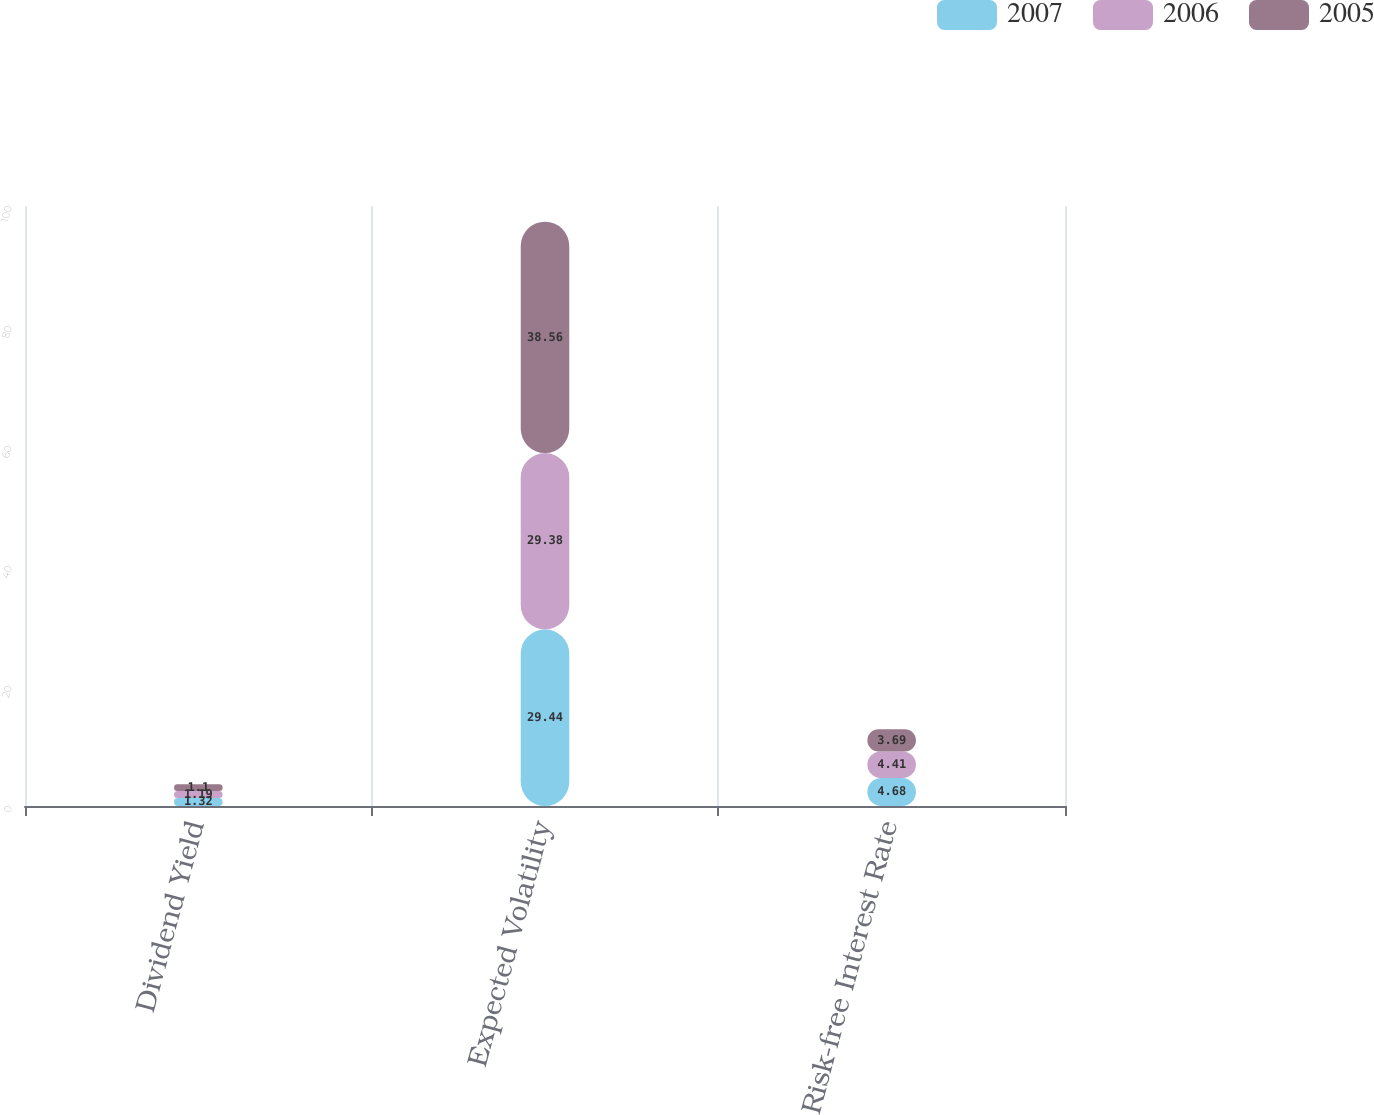Convert chart to OTSL. <chart><loc_0><loc_0><loc_500><loc_500><stacked_bar_chart><ecel><fcel>Dividend Yield<fcel>Expected Volatility<fcel>Risk-free Interest Rate<nl><fcel>2007<fcel>1.32<fcel>29.44<fcel>4.68<nl><fcel>2006<fcel>1.19<fcel>29.38<fcel>4.41<nl><fcel>2005<fcel>1.1<fcel>38.56<fcel>3.69<nl></chart> 